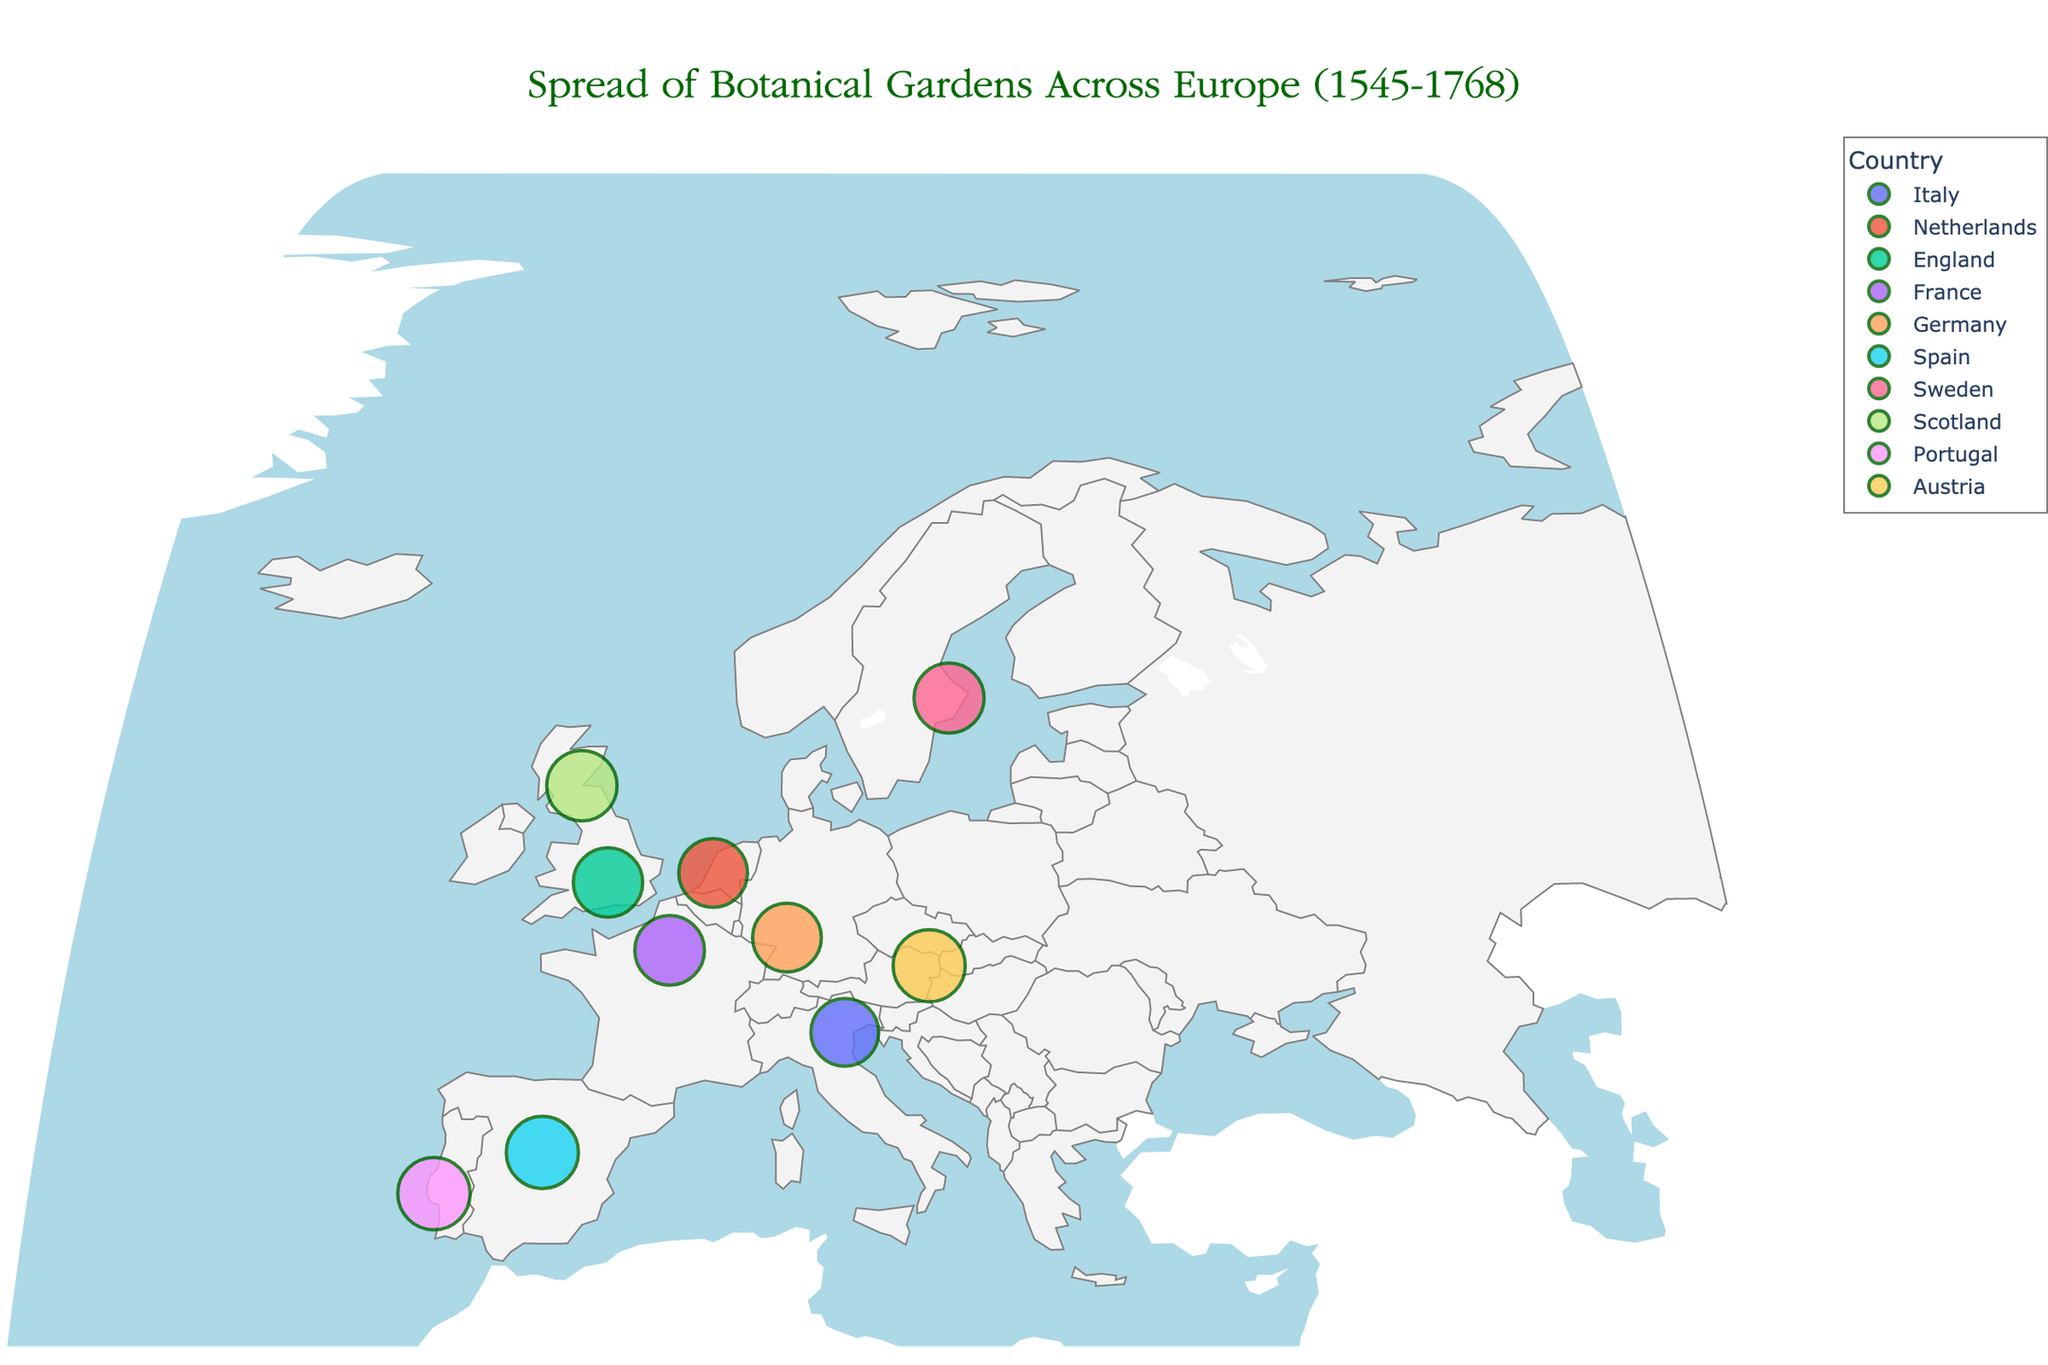Which botanical garden is the oldest on the map? To determine the oldest botanical garden, identify the garden with the earliest 'Year Established'. The Orto Botanico di Padova in Italy, established in 1545, is the oldest.
Answer: Orto Botanico di Padova What notable plant can you find in the University of Oxford Botanic Garden? Look at the information related to the University of Oxford Botanic Garden in the hover data. The notable plant listed is the English Yew.
Answer: English Yew Which country has the highest number of botanical gardens shown in the map? Count the number of botanical gardens each country has. England, Germany, Spain, Portugal, Sweden, Scotland, Italy, France, Austria, and the Netherlands each have one garden listed, so no single country has more gardens than any other.
Answer: Multiple countries Which botanical garden was established most recently? To find the most recently established garden, identify the one with the latest 'Year Established'. The Ajuda Botanical Garden in Lisbon, Portugal, established in 1768, is the most recent.
Answer: Ajuda Botanical Garden Compare the establishment years of the botanical gardens in Paris and Madrid. Which one was founded earlier? Compare the 'Year Established' of Jardin des Plantes in Paris (1635) and Real Jardín Botánico de Madrid (1755). The Jardin des Plantes in Paris was founded earlier.
Answer: Jardin des Plantes How many botanical gardens in the dataset were established in the 1600s? Count the gardens established between 1600 and 1699: University of Oxford Botanic Garden (1621), Jardin des Plantes (1635), Uppsala University Botanical Garden (1655), and Royal Botanic Garden Edinburgh (1670). There are four gardens.
Answer: 4 Which botanical garden is noted for the Cedar of Lebanon? Check the hover data for notable plants and find the garden associated with Cedar of Lebanon. It is Jardin des Plantes in Paris.
Answer: Jardin des Plantes Which two botanical gardens were established in the same year? Look for matching 'Year Established' values. Heidelberg University Botanical Garden and Hortus Botanicus Leiden were both established in the year 1593.
Answer: Heidelberg University Botanical Garden and Hortus Botanicus Leiden Compare the number of botanical gardens established before 1600 with those established after 1700. Which period saw more gardens established? Gardens before 1600: Orto Botanico di Padova (1545), Hortus Botanicus Leiden (1590), Heidelberg University Botanical Garden (1593). Total: 3. Gardens after 1700: Real Jardín Botánico de Madrid (1755), University of Vienna Botanical Garden (1754), Ajuda Botanical Garden (1768). Total: 3. Both periods saw the same number of gardens established.
Answer: Equal 